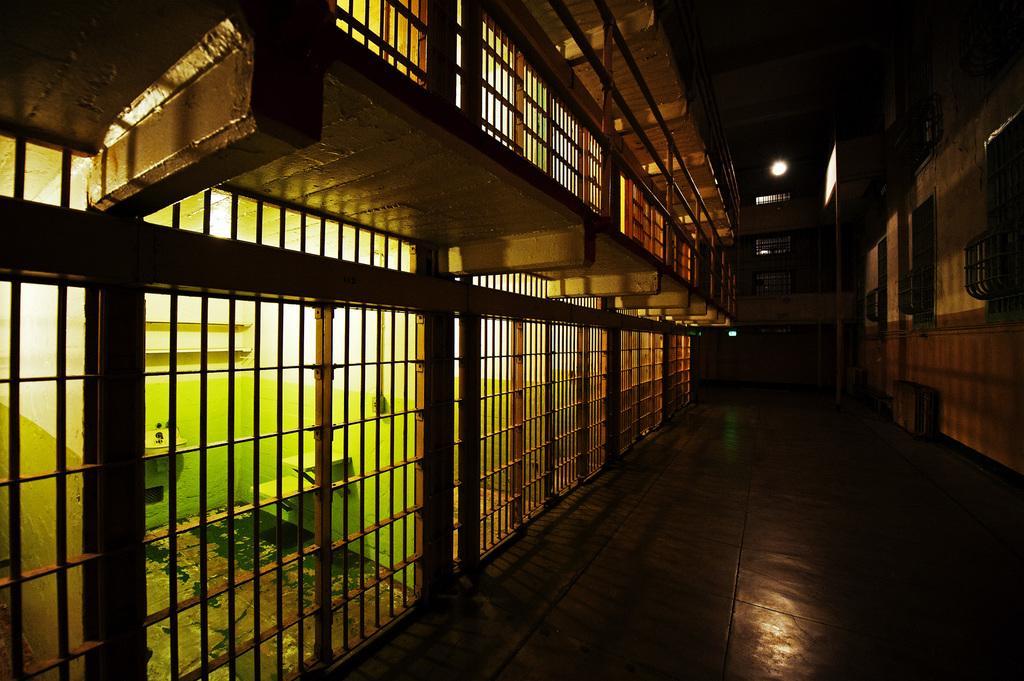In one or two sentences, can you explain what this image depicts? In this image I can see a fence, wall, windows and a light. This image is taken may be in a hall. 